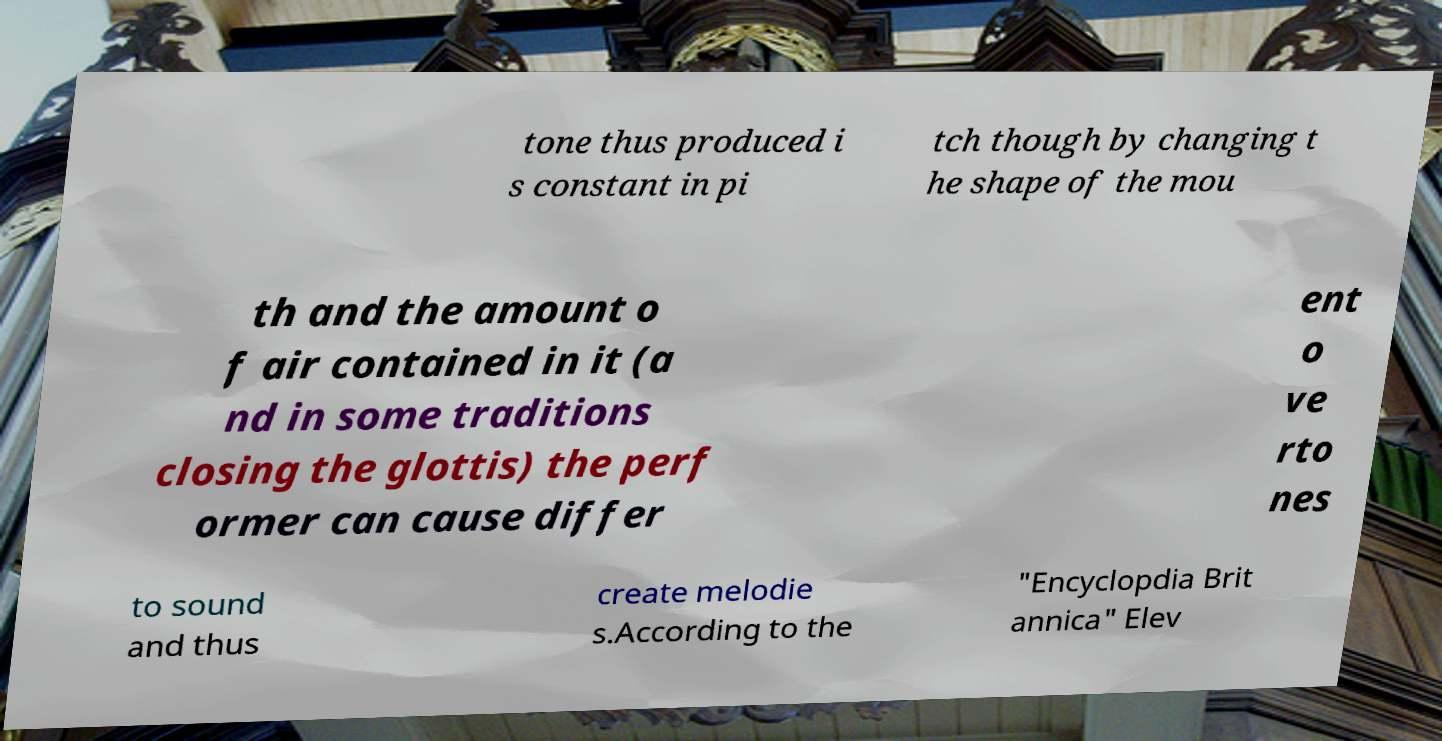Can you read and provide the text displayed in the image?This photo seems to have some interesting text. Can you extract and type it out for me? tone thus produced i s constant in pi tch though by changing t he shape of the mou th and the amount o f air contained in it (a nd in some traditions closing the glottis) the perf ormer can cause differ ent o ve rto nes to sound and thus create melodie s.According to the "Encyclopdia Brit annica" Elev 